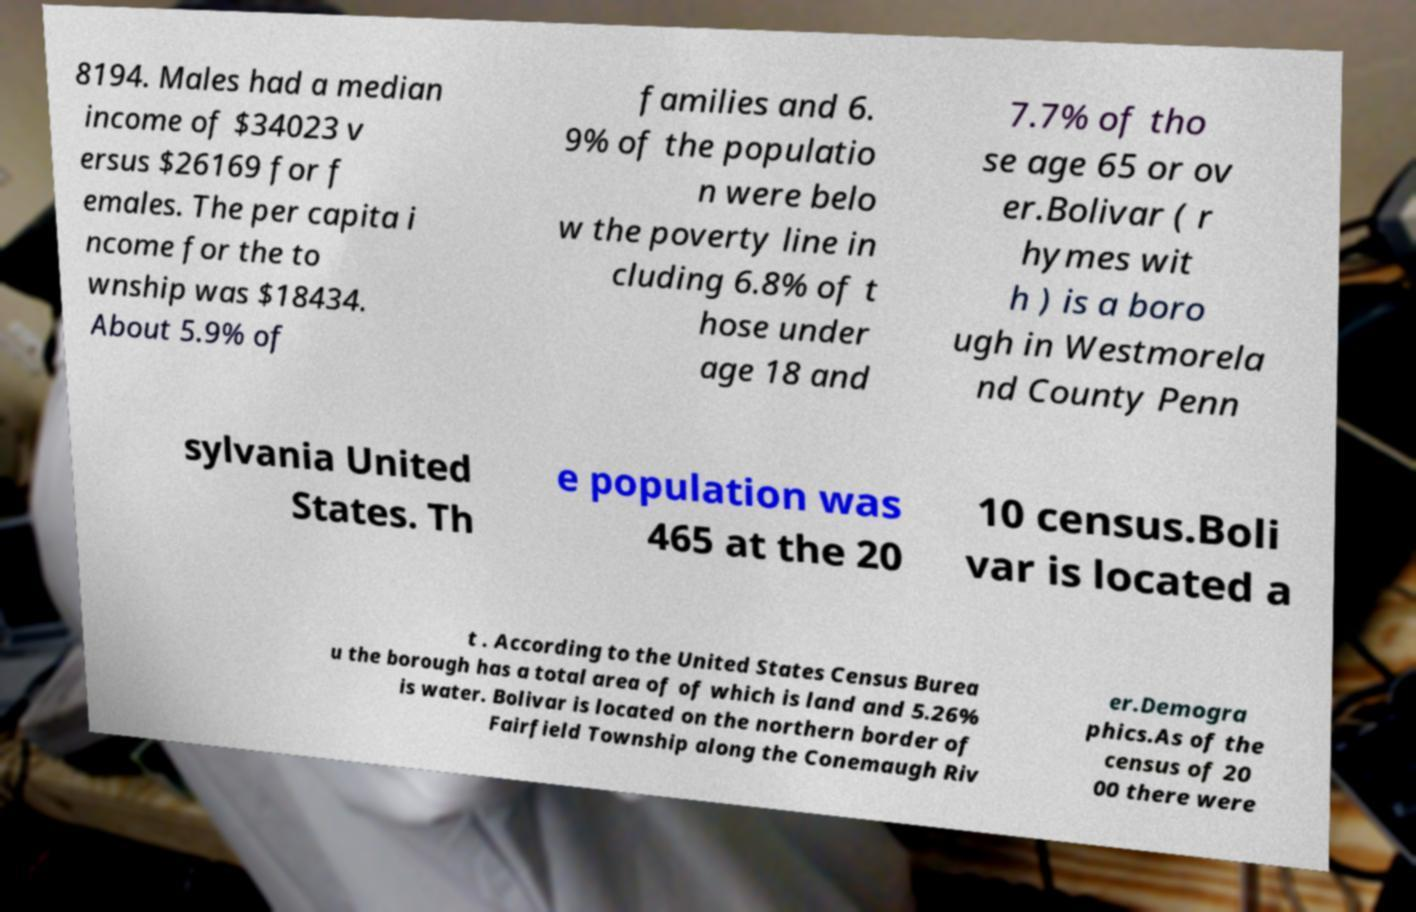What messages or text are displayed in this image? I need them in a readable, typed format. 8194. Males had a median income of $34023 v ersus $26169 for f emales. The per capita i ncome for the to wnship was $18434. About 5.9% of families and 6. 9% of the populatio n were belo w the poverty line in cluding 6.8% of t hose under age 18 and 7.7% of tho se age 65 or ov er.Bolivar ( r hymes wit h ) is a boro ugh in Westmorela nd County Penn sylvania United States. Th e population was 465 at the 20 10 census.Boli var is located a t . According to the United States Census Burea u the borough has a total area of of which is land and 5.26% is water. Bolivar is located on the northern border of Fairfield Township along the Conemaugh Riv er.Demogra phics.As of the census of 20 00 there were 